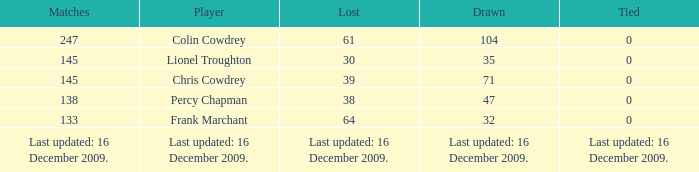Specify the tie that ended in a 71 draw. 0.0. 